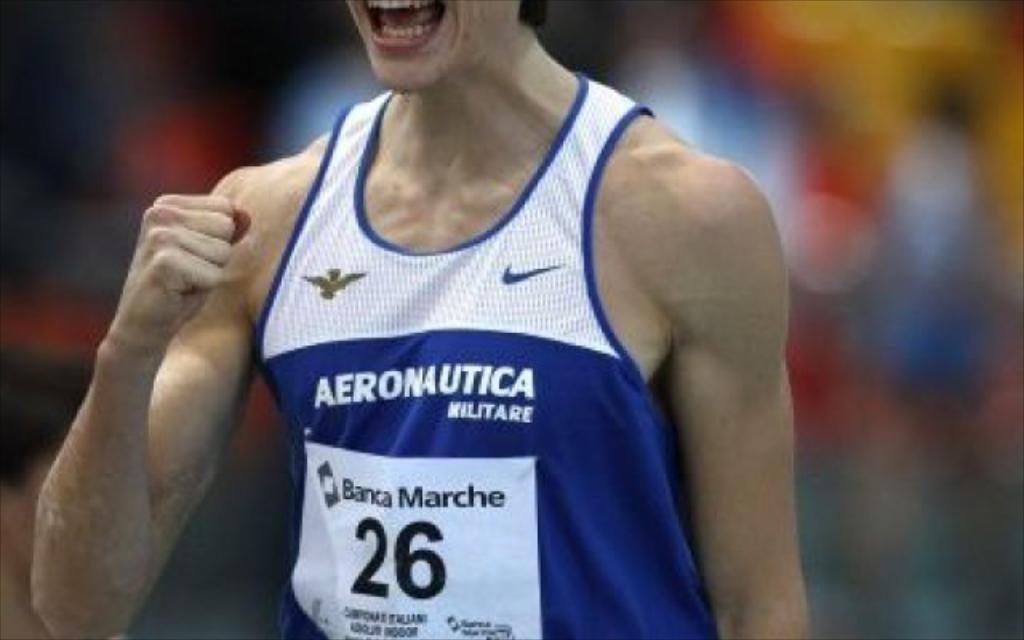<image>
Present a compact description of the photo's key features. A male sports player wearing a blue and white tank top jersey that says Aeronautica. 